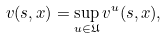<formula> <loc_0><loc_0><loc_500><loc_500>v ( s , x ) = \sup _ { u \in \mathfrak { U } } v ^ { u } ( s , x ) ,</formula> 